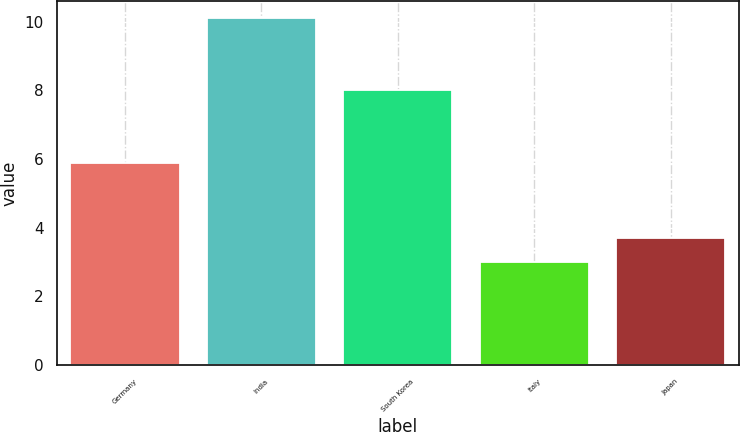Convert chart. <chart><loc_0><loc_0><loc_500><loc_500><bar_chart><fcel>Germany<fcel>India<fcel>South Korea<fcel>Italy<fcel>Japan<nl><fcel>5.9<fcel>10.1<fcel>8<fcel>3<fcel>3.71<nl></chart> 